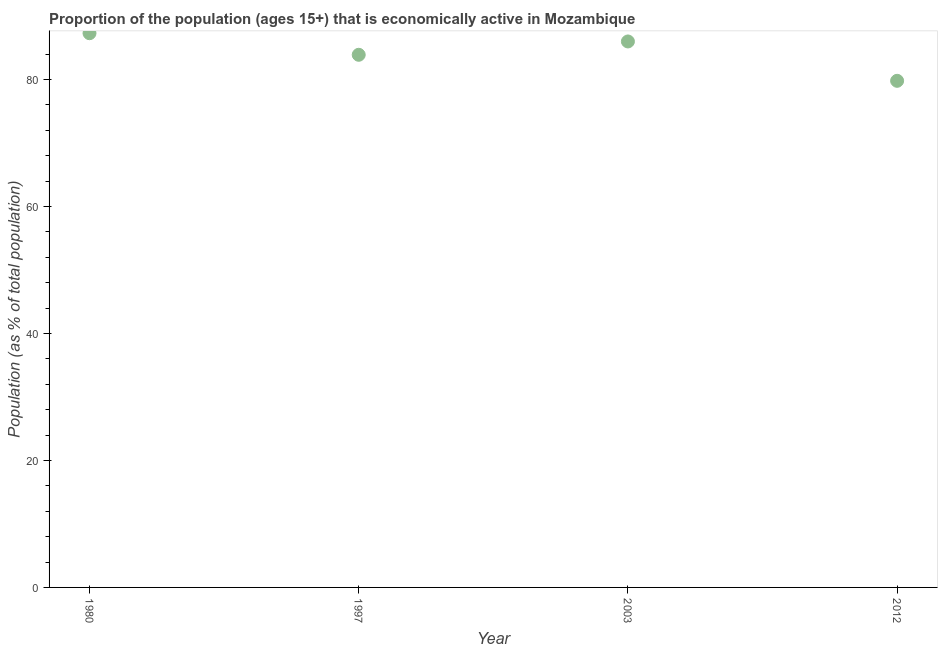What is the percentage of economically active population in 2003?
Offer a terse response. 86. Across all years, what is the maximum percentage of economically active population?
Your answer should be very brief. 87.3. Across all years, what is the minimum percentage of economically active population?
Provide a short and direct response. 79.8. In which year was the percentage of economically active population minimum?
Your answer should be compact. 2012. What is the sum of the percentage of economically active population?
Provide a succinct answer. 337. What is the difference between the percentage of economically active population in 1980 and 2012?
Provide a succinct answer. 7.5. What is the average percentage of economically active population per year?
Offer a very short reply. 84.25. What is the median percentage of economically active population?
Keep it short and to the point. 84.95. What is the ratio of the percentage of economically active population in 1980 to that in 2012?
Your answer should be compact. 1.09. What is the difference between the highest and the second highest percentage of economically active population?
Ensure brevity in your answer.  1.3. In how many years, is the percentage of economically active population greater than the average percentage of economically active population taken over all years?
Offer a very short reply. 2. Does the percentage of economically active population monotonically increase over the years?
Give a very brief answer. No. How many dotlines are there?
Provide a succinct answer. 1. What is the title of the graph?
Provide a succinct answer. Proportion of the population (ages 15+) that is economically active in Mozambique. What is the label or title of the Y-axis?
Provide a short and direct response. Population (as % of total population). What is the Population (as % of total population) in 1980?
Give a very brief answer. 87.3. What is the Population (as % of total population) in 1997?
Provide a short and direct response. 83.9. What is the Population (as % of total population) in 2012?
Offer a very short reply. 79.8. What is the difference between the Population (as % of total population) in 1980 and 1997?
Give a very brief answer. 3.4. What is the difference between the Population (as % of total population) in 1980 and 2012?
Offer a terse response. 7.5. What is the difference between the Population (as % of total population) in 1997 and 2003?
Provide a succinct answer. -2.1. What is the difference between the Population (as % of total population) in 1997 and 2012?
Keep it short and to the point. 4.1. What is the difference between the Population (as % of total population) in 2003 and 2012?
Offer a terse response. 6.2. What is the ratio of the Population (as % of total population) in 1980 to that in 1997?
Your answer should be compact. 1.04. What is the ratio of the Population (as % of total population) in 1980 to that in 2012?
Your answer should be very brief. 1.09. What is the ratio of the Population (as % of total population) in 1997 to that in 2003?
Give a very brief answer. 0.98. What is the ratio of the Population (as % of total population) in 1997 to that in 2012?
Your answer should be very brief. 1.05. What is the ratio of the Population (as % of total population) in 2003 to that in 2012?
Provide a short and direct response. 1.08. 